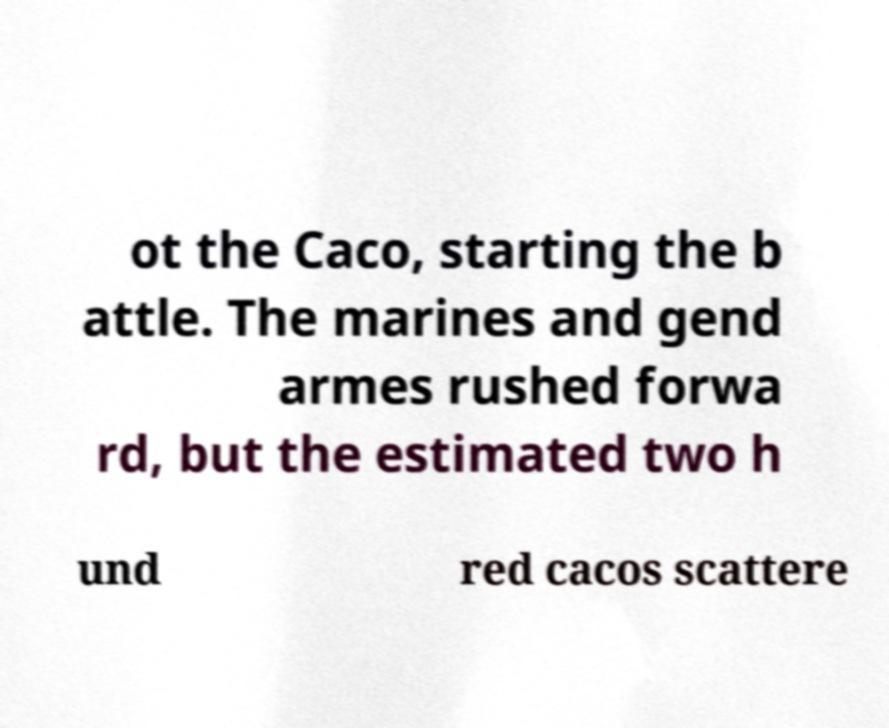What messages or text are displayed in this image? I need them in a readable, typed format. ot the Caco, starting the b attle. The marines and gend armes rushed forwa rd, but the estimated two h und red cacos scattere 